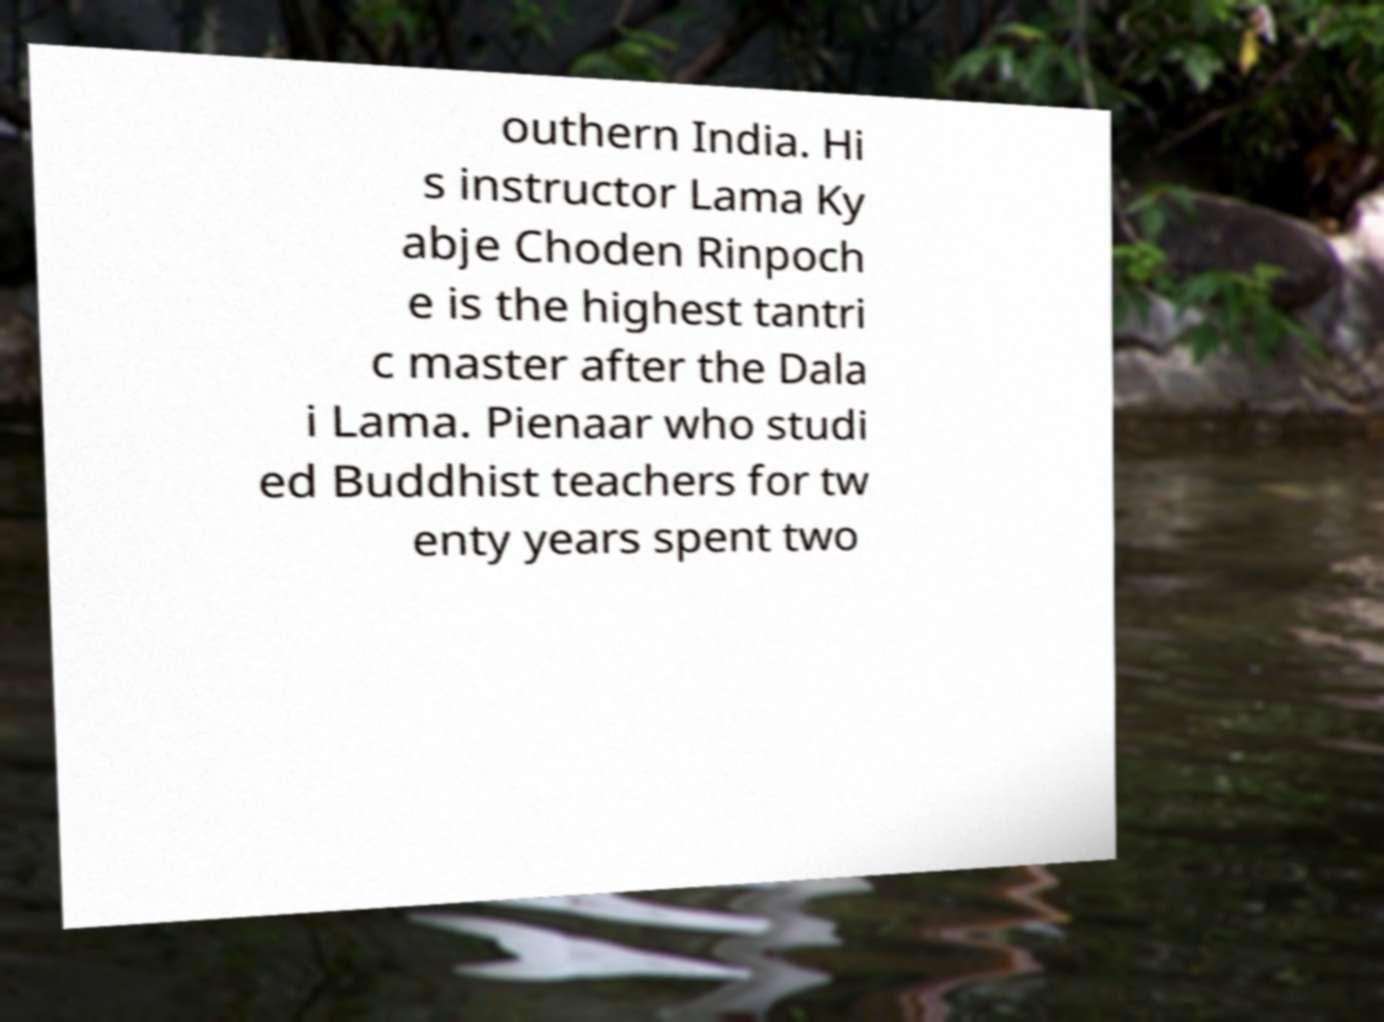Please identify and transcribe the text found in this image. outhern India. Hi s instructor Lama Ky abje Choden Rinpoch e is the highest tantri c master after the Dala i Lama. Pienaar who studi ed Buddhist teachers for tw enty years spent two 